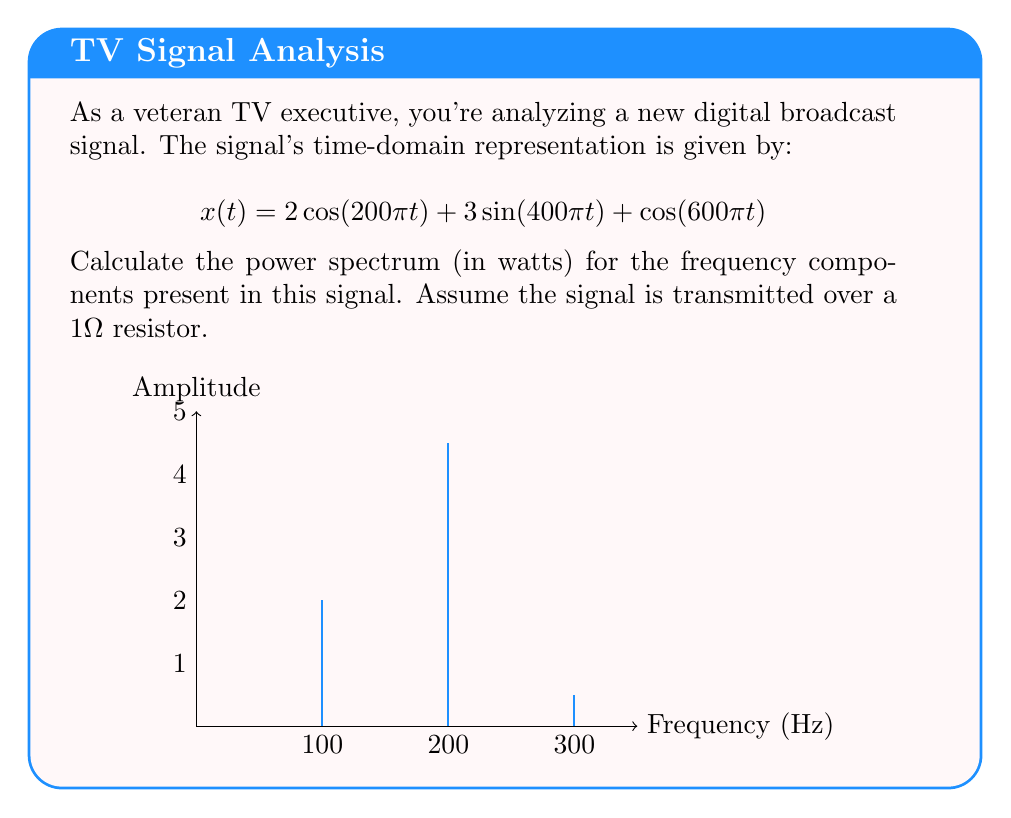Show me your answer to this math problem. Let's approach this step-by-step:

1) The power spectrum shows the power distribution across different frequencies. For a sinusoidal signal, the power is proportional to the square of its amplitude.

2) First, we need to identify the frequencies and amplitudes in the signal:
   - $2\cos(200\pi t)$ has frequency 100 Hz and amplitude 2
   - $3\sin(400\pi t)$ has frequency 200 Hz and amplitude 3
   - $\cos(600\pi t)$ has frequency 300 Hz and amplitude 1

3) For a cosine or sine wave with amplitude $A$, the power is given by $\frac{A^2}{2}$ watts when transmitted over a 1Ω resistor.

4) Let's calculate the power for each component:
   - For 100 Hz: $P_{100} = \frac{2^2}{2} = 2$ W
   - For 200 Hz: $P_{200} = \frac{3^2}{2} = 4.5$ W
   - For 300 Hz: $P_{300} = \frac{1^2}{2} = 0.5$ W

5) The power spectrum is the set of these power values at their respective frequencies.
Answer: {(100 Hz, 2 W), (200 Hz, 4.5 W), (300 Hz, 0.5 W)} 